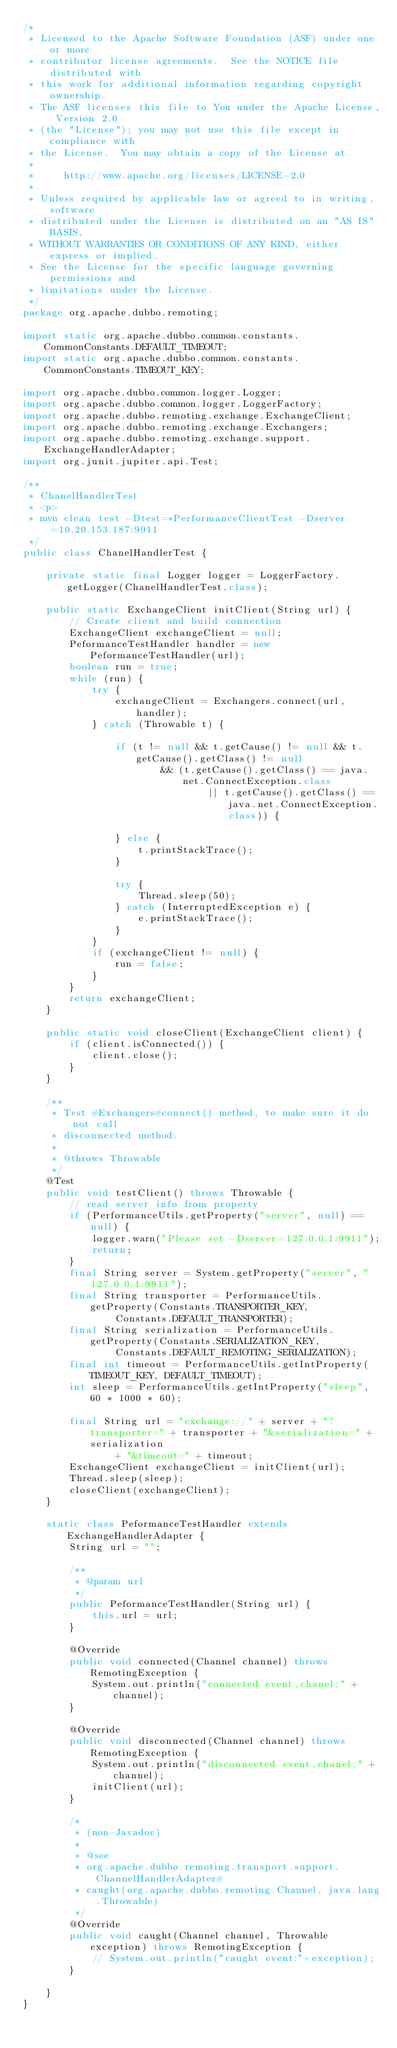Convert code to text. <code><loc_0><loc_0><loc_500><loc_500><_Java_>/*
 * Licensed to the Apache Software Foundation (ASF) under one or more
 * contributor license agreements.  See the NOTICE file distributed with
 * this work for additional information regarding copyright ownership.
 * The ASF licenses this file to You under the Apache License, Version 2.0
 * (the "License"); you may not use this file except in compliance with
 * the License.  You may obtain a copy of the License at
 *
 *     http://www.apache.org/licenses/LICENSE-2.0
 *
 * Unless required by applicable law or agreed to in writing, software
 * distributed under the License is distributed on an "AS IS" BASIS,
 * WITHOUT WARRANTIES OR CONDITIONS OF ANY KIND, either express or implied.
 * See the License for the specific language governing permissions and
 * limitations under the License.
 */
package org.apache.dubbo.remoting;

import static org.apache.dubbo.common.constants.CommonConstants.DEFAULT_TIMEOUT;
import static org.apache.dubbo.common.constants.CommonConstants.TIMEOUT_KEY;

import org.apache.dubbo.common.logger.Logger;
import org.apache.dubbo.common.logger.LoggerFactory;
import org.apache.dubbo.remoting.exchange.ExchangeClient;
import org.apache.dubbo.remoting.exchange.Exchangers;
import org.apache.dubbo.remoting.exchange.support.ExchangeHandlerAdapter;
import org.junit.jupiter.api.Test;

/**
 * ChanelHandlerTest
 * <p>
 * mvn clean test -Dtest=*PerformanceClientTest -Dserver=10.20.153.187:9911
 */
public class ChanelHandlerTest {

	private static final Logger logger = LoggerFactory.getLogger(ChanelHandlerTest.class);

	public static ExchangeClient initClient(String url) {
		// Create client and build connection
		ExchangeClient exchangeClient = null;
		PeformanceTestHandler handler = new PeformanceTestHandler(url);
		boolean run = true;
		while (run) {
			try {
				exchangeClient = Exchangers.connect(url, handler);
			} catch (Throwable t) {

				if (t != null && t.getCause() != null && t.getCause().getClass() != null
						&& (t.getCause().getClass() == java.net.ConnectException.class
								|| t.getCause().getClass() == java.net.ConnectException.class)) {

				} else {
					t.printStackTrace();
				}

				try {
					Thread.sleep(50);
				} catch (InterruptedException e) {
					e.printStackTrace();
				}
			}
			if (exchangeClient != null) {
				run = false;
			}
		}
		return exchangeClient;
	}

	public static void closeClient(ExchangeClient client) {
		if (client.isConnected()) {
			client.close();
		}
	}

	/**
	 * Test #Exchangers#connect() method, to make sure it do not call
	 * disconnected method.
	 * 
	 * @throws Throwable
	 */
	@Test
	public void testClient() throws Throwable {
		// read server info from property
		if (PerformanceUtils.getProperty("server", null) == null) {
			logger.warn("Please set -Dserver=127.0.0.1:9911");
			return;
		}
		final String server = System.getProperty("server", "127.0.0.1:9911");
		final String transporter = PerformanceUtils.getProperty(Constants.TRANSPORTER_KEY,
				Constants.DEFAULT_TRANSPORTER);
		final String serialization = PerformanceUtils.getProperty(Constants.SERIALIZATION_KEY,
				Constants.DEFAULT_REMOTING_SERIALIZATION);
		final int timeout = PerformanceUtils.getIntProperty(TIMEOUT_KEY, DEFAULT_TIMEOUT);
		int sleep = PerformanceUtils.getIntProperty("sleep", 60 * 1000 * 60);

		final String url = "exchange://" + server + "?transporter=" + transporter + "&serialization=" + serialization
				+ "&timeout=" + timeout;
		ExchangeClient exchangeClient = initClient(url);
		Thread.sleep(sleep);
		closeClient(exchangeClient);
	}

	static class PeformanceTestHandler extends ExchangeHandlerAdapter {
		String url = "";

		/**
		 * @param url
		 */
		public PeformanceTestHandler(String url) {
			this.url = url;
		}

		@Override
		public void connected(Channel channel) throws RemotingException {
			System.out.println("connected event,chanel;" + channel);
		}

		@Override
		public void disconnected(Channel channel) throws RemotingException {
			System.out.println("disconnected event,chanel;" + channel);
			initClient(url);
		}

		/*
		 * (non-Javadoc)
		 * 
		 * @see
		 * org.apache.dubbo.remoting.transport.support.ChannelHandlerAdapter#
		 * caught(org.apache.dubbo.remoting.Channel, java.lang.Throwable)
		 */
		@Override
		public void caught(Channel channel, Throwable exception) throws RemotingException {
			// System.out.println("caught event:"+exception);
		}

	}
}
</code> 